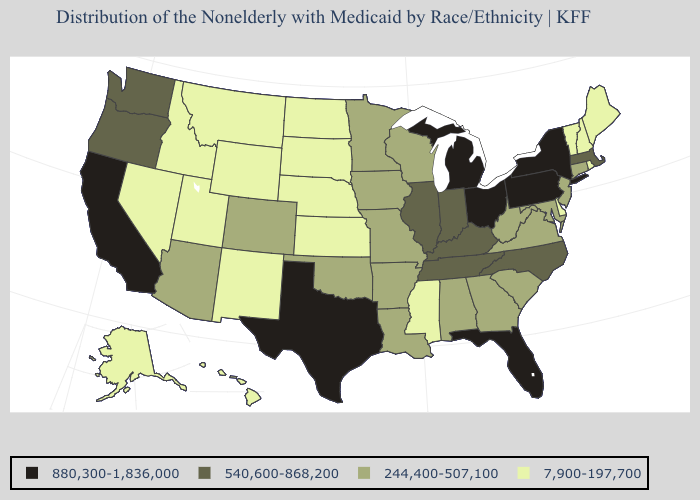Which states hav the highest value in the MidWest?
Be succinct. Michigan, Ohio. What is the value of Arkansas?
Short answer required. 244,400-507,100. Which states have the lowest value in the West?
Write a very short answer. Alaska, Hawaii, Idaho, Montana, Nevada, New Mexico, Utah, Wyoming. Name the states that have a value in the range 7,900-197,700?
Be succinct. Alaska, Delaware, Hawaii, Idaho, Kansas, Maine, Mississippi, Montana, Nebraska, Nevada, New Hampshire, New Mexico, North Dakota, Rhode Island, South Dakota, Utah, Vermont, Wyoming. How many symbols are there in the legend?
Concise answer only. 4. What is the lowest value in states that border Rhode Island?
Give a very brief answer. 244,400-507,100. What is the lowest value in the Northeast?
Short answer required. 7,900-197,700. Name the states that have a value in the range 7,900-197,700?
Short answer required. Alaska, Delaware, Hawaii, Idaho, Kansas, Maine, Mississippi, Montana, Nebraska, Nevada, New Hampshire, New Mexico, North Dakota, Rhode Island, South Dakota, Utah, Vermont, Wyoming. Which states have the highest value in the USA?
Short answer required. California, Florida, Michigan, New York, Ohio, Pennsylvania, Texas. What is the value of New Mexico?
Concise answer only. 7,900-197,700. What is the value of New Hampshire?
Write a very short answer. 7,900-197,700. Which states have the lowest value in the MidWest?
Give a very brief answer. Kansas, Nebraska, North Dakota, South Dakota. Which states have the lowest value in the USA?
Quick response, please. Alaska, Delaware, Hawaii, Idaho, Kansas, Maine, Mississippi, Montana, Nebraska, Nevada, New Hampshire, New Mexico, North Dakota, Rhode Island, South Dakota, Utah, Vermont, Wyoming. What is the highest value in the MidWest ?
Concise answer only. 880,300-1,836,000. What is the value of New York?
Be succinct. 880,300-1,836,000. 